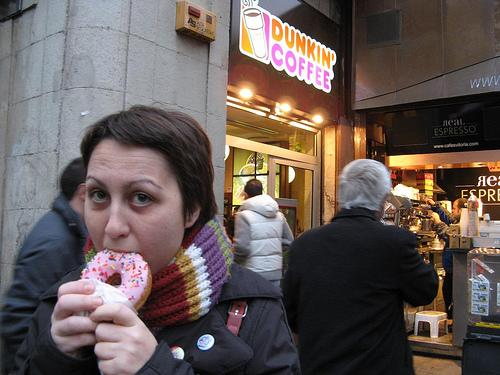What is the woman eating the donut wearing?

Choices:
A) crown
B) scarf
C) hat
D) armor scarf 